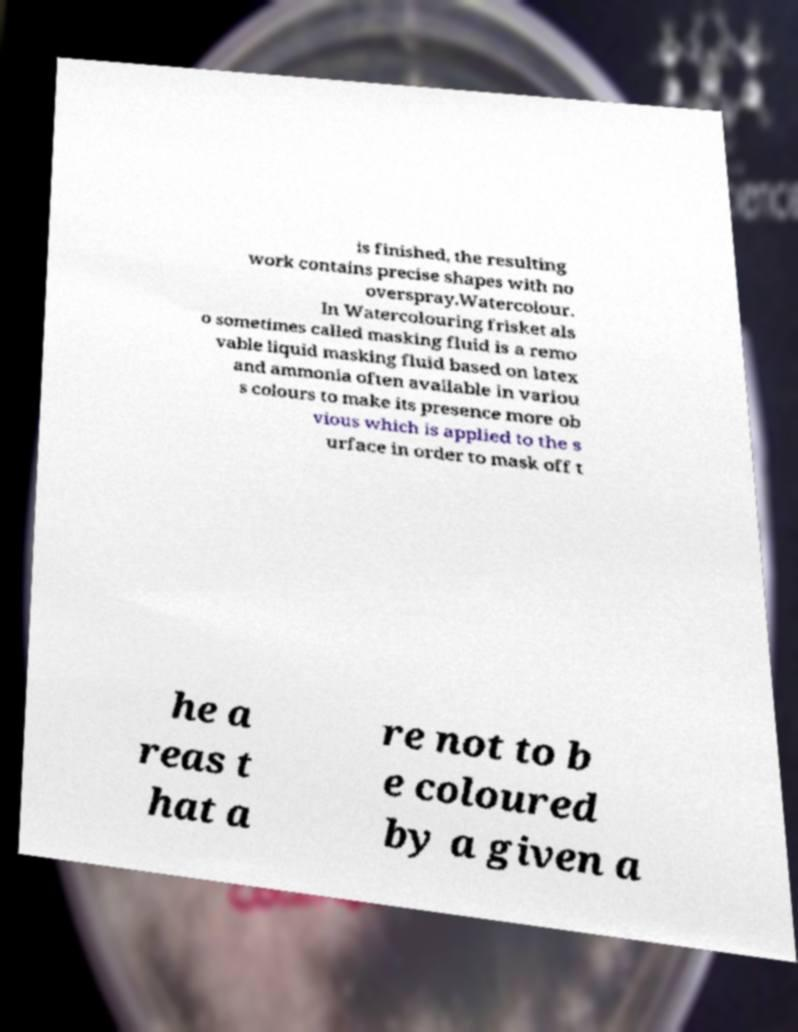Can you read and provide the text displayed in the image?This photo seems to have some interesting text. Can you extract and type it out for me? is finished, the resulting work contains precise shapes with no overspray.Watercolour. In Watercolouring frisket als o sometimes called masking fluid is a remo vable liquid masking fluid based on latex and ammonia often available in variou s colours to make its presence more ob vious which is applied to the s urface in order to mask off t he a reas t hat a re not to b e coloured by a given a 